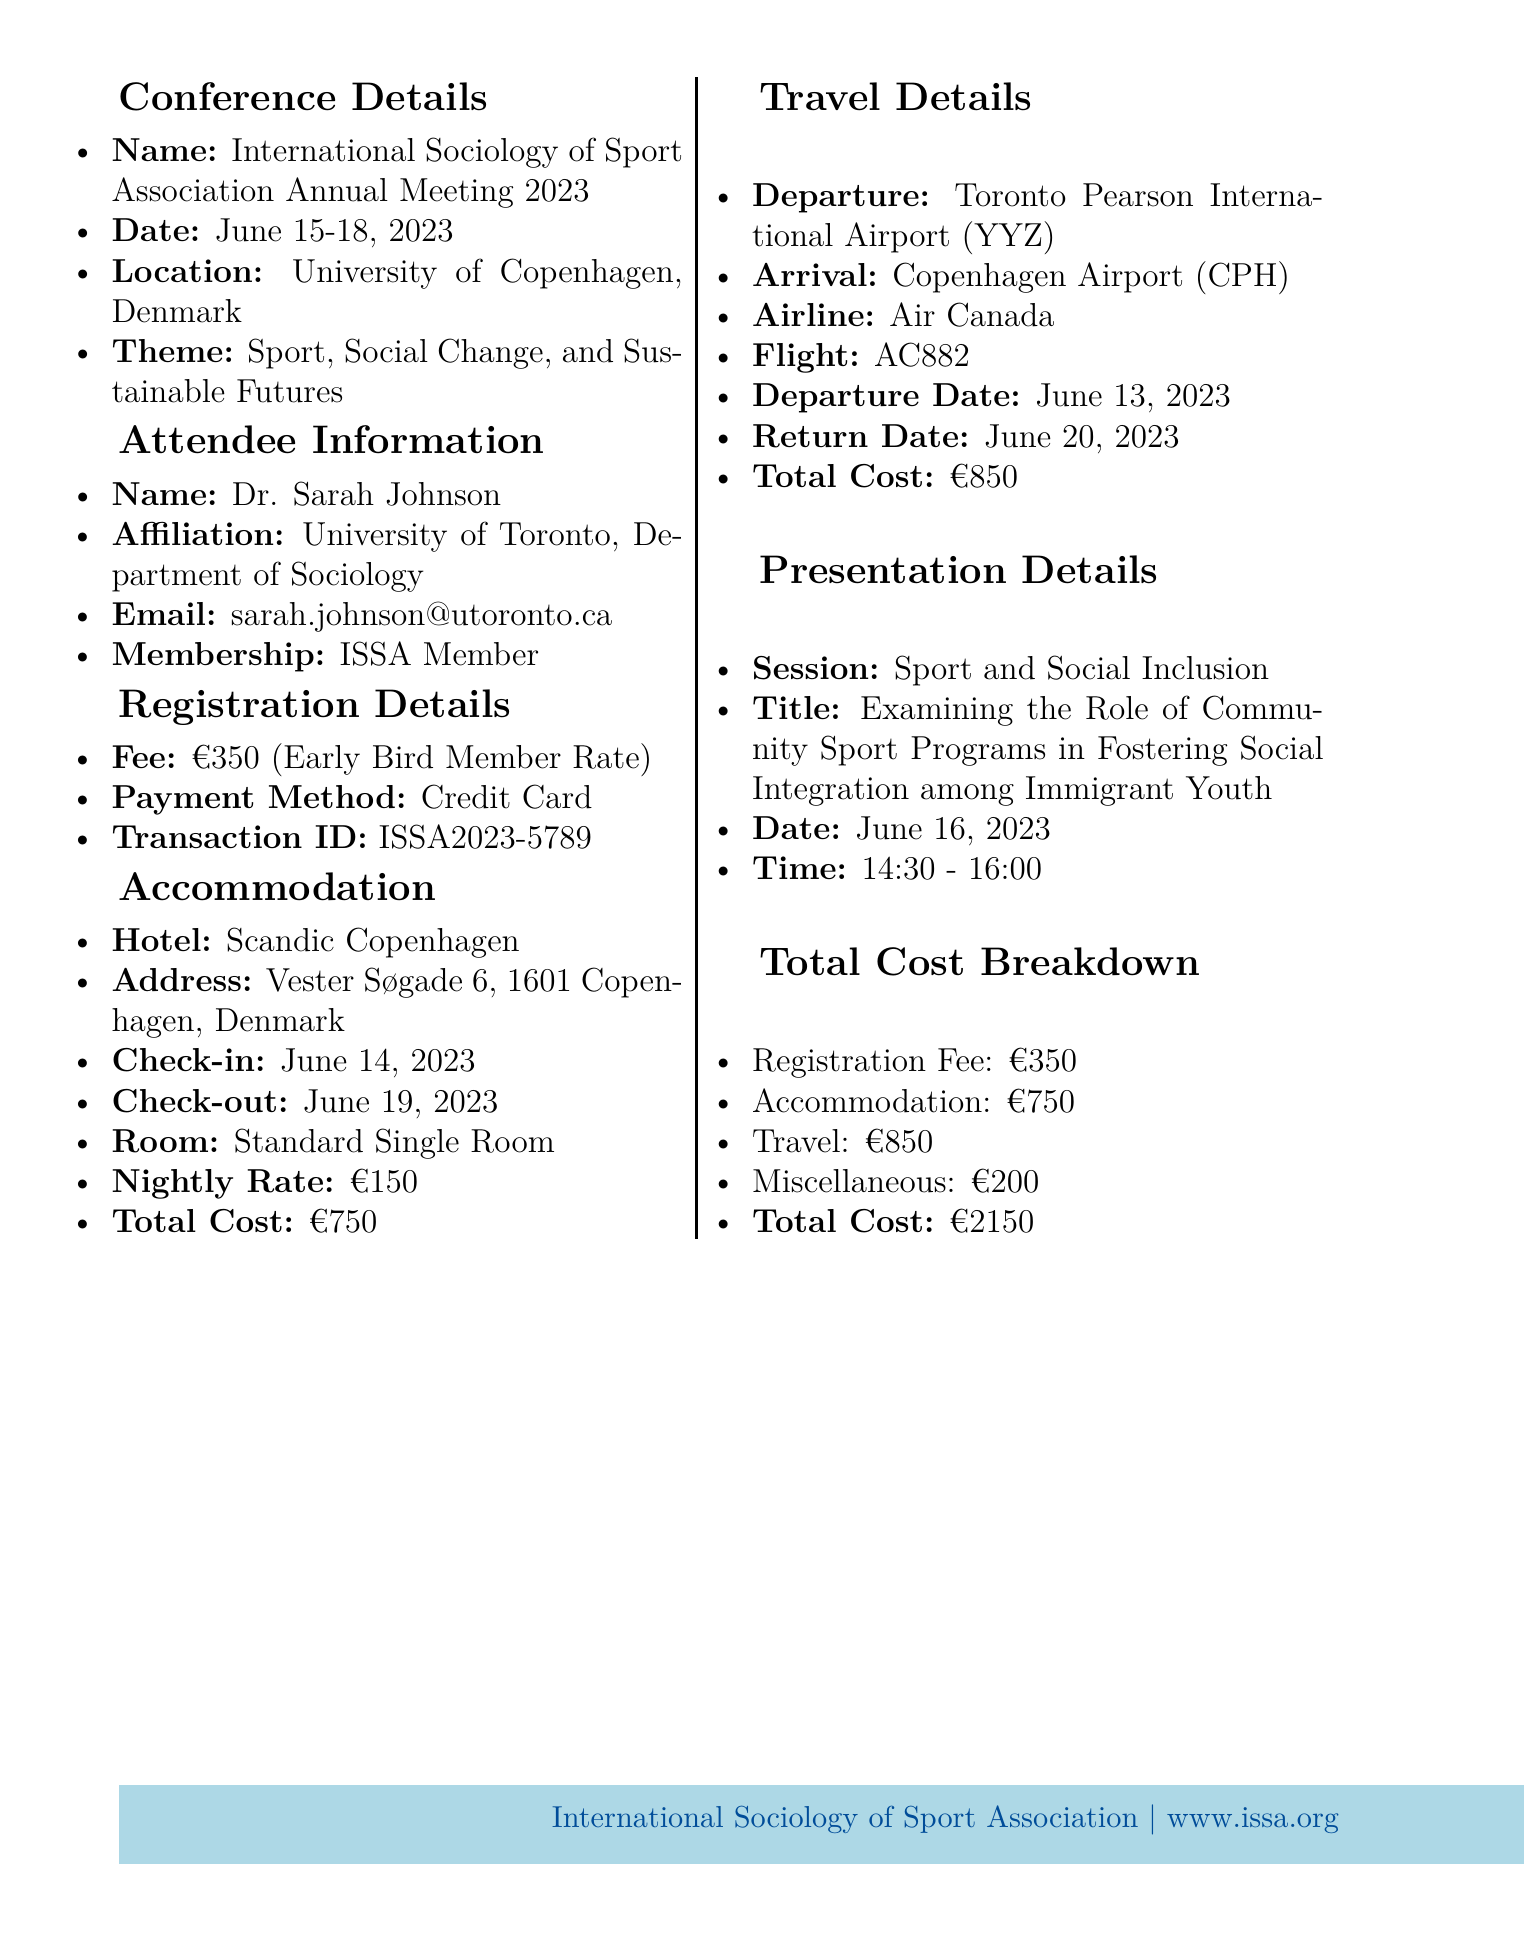What is the name of the conference? The conference name is explicitly mentioned in the document as the "International Sociology of Sport Association Annual Meeting 2023."
Answer: International Sociology of Sport Association Annual Meeting 2023 What is the theme of the conference? The theme is provided conveniently within the conference details section of the document.
Answer: Sport, Social Change, and Sustainable Futures What is the total cost of accommodation? The total accommodation cost is calculated in the cost breakdown section, specifically for hotel stays.
Answer: €750 Who is the keynote speaker? The document lists the keynote speaker under conference program highlights.
Answer: Prof. Elizabeth Pike, University of Hertfordshire When is Dr. Sarah Johnson's presentation scheduled? The presentation date and time can be found in the presentation details section of the document.
Answer: June 16, 2023, 14:30 - 16:00 What is the registration fee for ISSA members? The early bird member rate is specified under registration details.
Answer: €350 Which hotel will Dr. Sarah Johnson be staying at? The hotel name is mentioned directly in the accommodation section for clarity.
Answer: Scandic Copenhagen What is the total travel cost? Total travel cost is provided in the travel details section of the document.
Answer: €850 What is the transaction ID for the payment? The transaction ID is listed clearly under registration details.
Answer: ISSA2023-5789 